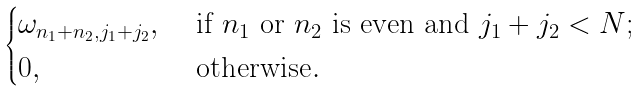<formula> <loc_0><loc_0><loc_500><loc_500>\begin{cases} \omega _ { n _ { 1 } + n _ { 2 } , j _ { 1 } + j _ { 2 } } , & \text { if $n_{1}$ or $n_{2}$ is even and $j_{1}+j_{2}<N$} ; \\ 0 , & \text { otherwise} . \end{cases}</formula> 